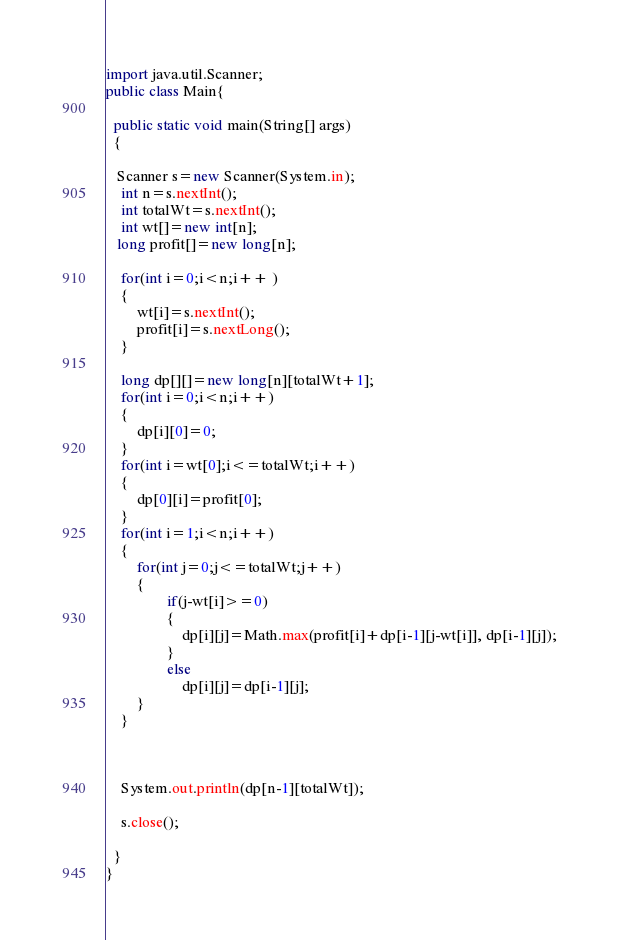<code> <loc_0><loc_0><loc_500><loc_500><_Java_>


import java.util.Scanner;
public class Main{
 
  public static void main(String[] args)
  {
     
   Scanner s=new Scanner(System.in);
    int n=s.nextInt();
    int totalWt=s.nextInt();
    int wt[]=new int[n];
   long profit[]=new long[n];
    
    for(int i=0;i<n;i++ )
    {
    	wt[i]=s.nextInt();
    	profit[i]=s.nextLong();
    }
    
    long dp[][]=new long[n][totalWt+1];
    for(int i=0;i<n;i++)
    {
    	dp[i][0]=0;
    }
    for(int i=wt[0];i<=totalWt;i++)
    {
    	dp[0][i]=profit[0];
    }
    for(int i=1;i<n;i++)
    {
    	for(int j=0;j<=totalWt;j++)
    	{
           		if(j-wt[i]>=0)
           		{
           			dp[i][j]=Math.max(profit[i]+dp[i-1][j-wt[i]], dp[i-1][j]);
           		}
           		else
           			dp[i][j]=dp[i-1][j];
    	}
    }
    
    
   
    System.out.println(dp[n-1][totalWt]);
    
    s.close();
    
  }
}</code> 